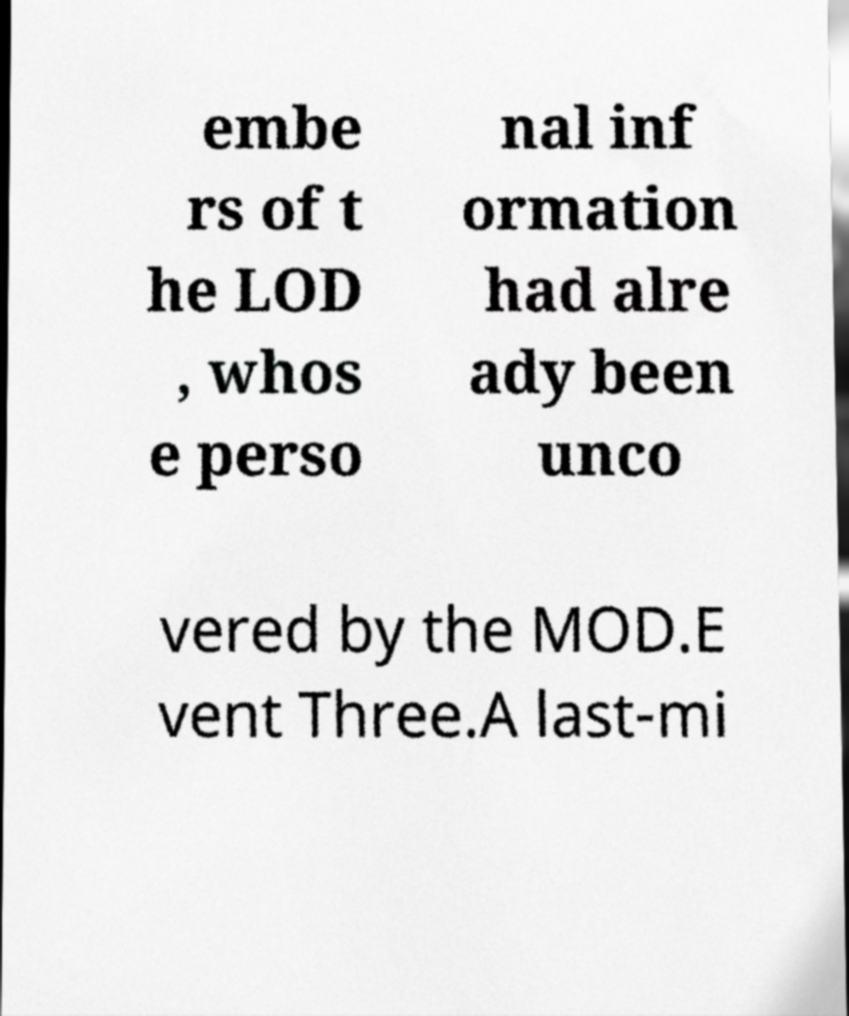What messages or text are displayed in this image? I need them in a readable, typed format. embe rs of t he LOD , whos e perso nal inf ormation had alre ady been unco vered by the MOD.E vent Three.A last-mi 